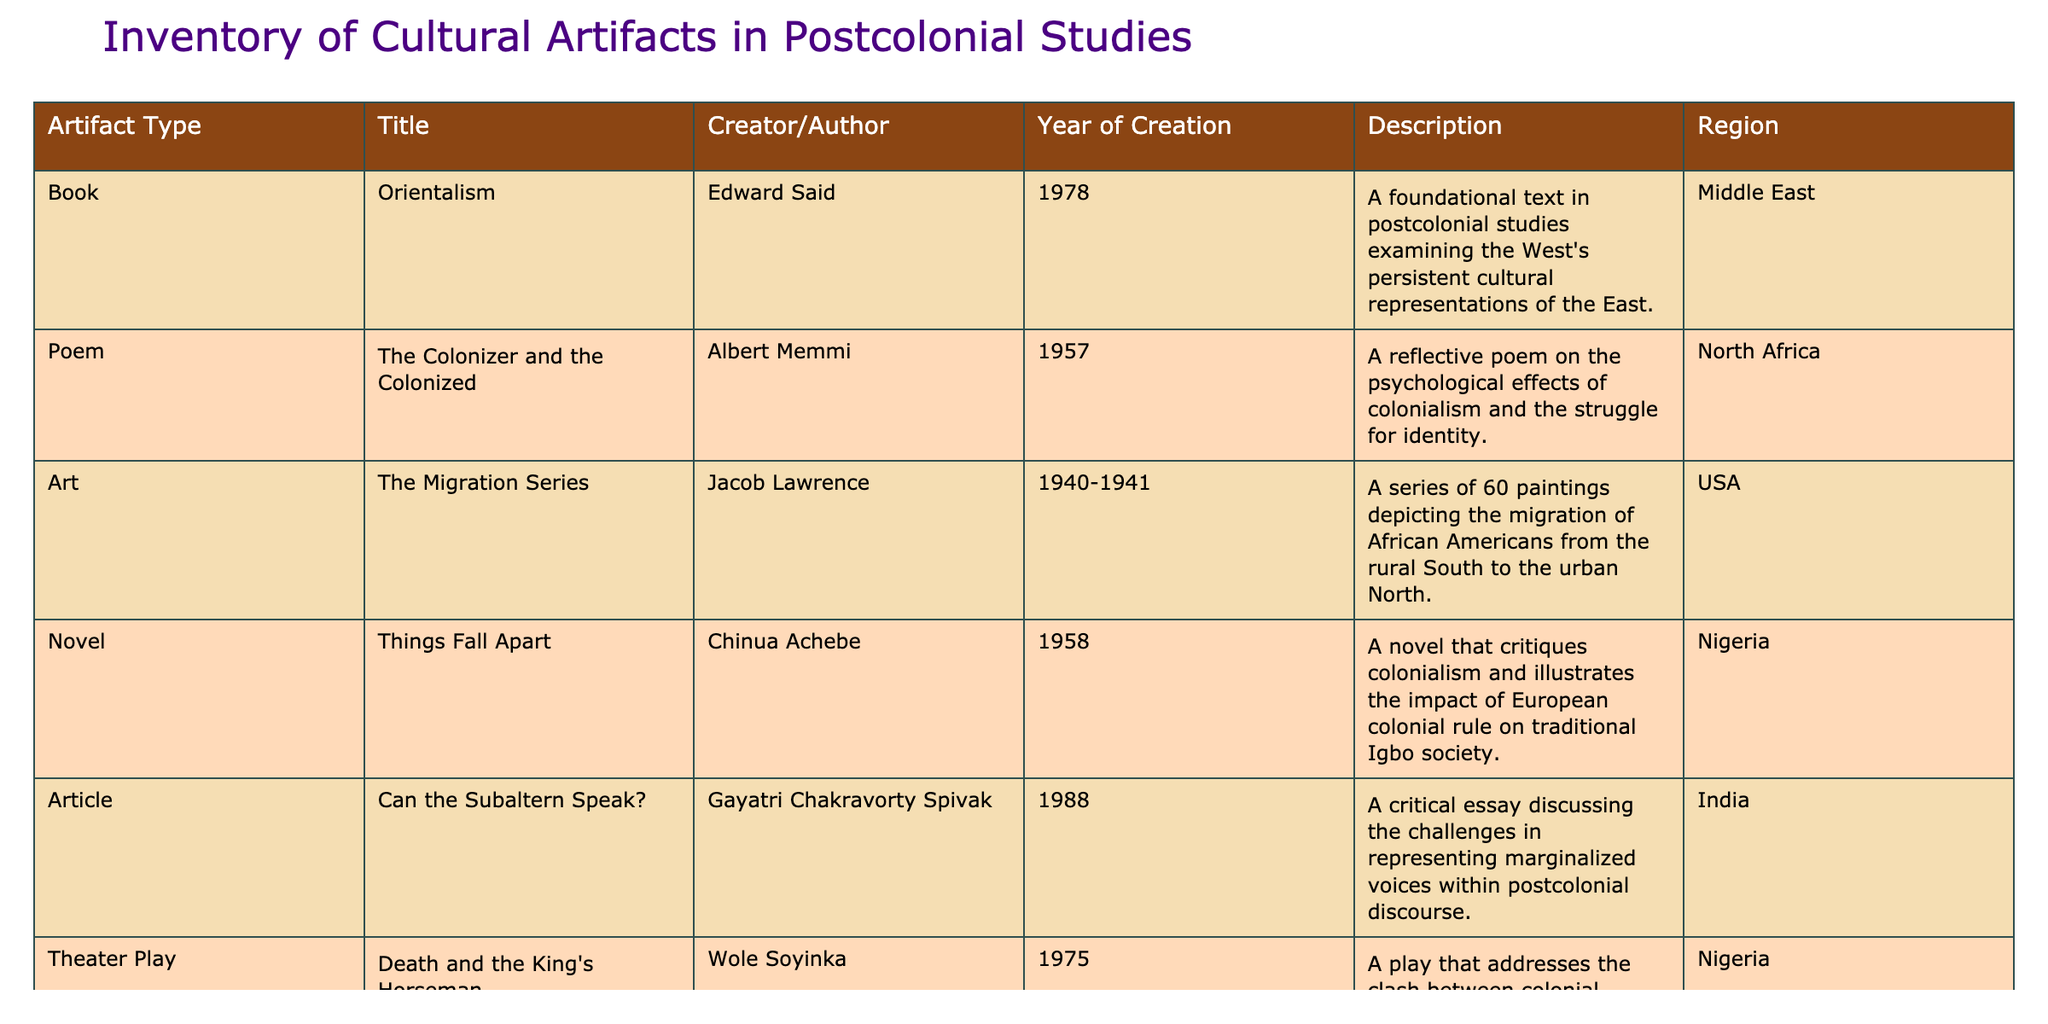What is the title of the book by Edward Said? The table lists Edward Said's work, which is classified as a book under "Title." The title mentioned alongside Edward Said is "Orientalism."
Answer: Orientalism How many artifacts listed were created by authors from Nigeria? The table shows two entries where the Region is Nigeria—"Things Fall Apart" by Chinua Achebe and "Death and the King's Horseman" by Wole Soyinka.
Answer: 2 Is "The Act of Killing" a novel? The table specifies that "The Act of Killing" is categorized as a documentary, not a novel; thus, the statement is false.
Answer: No What is the medium of "The Colonizer and the Colonized"? The table states that "The Colonizer and the Colonized" is classified as a poem. This is directly referenced in the Artifact Type column.
Answer: Poem Which artifact created in 1975 addresses colonial powers and indigenous practices? The table indicates that "Death and the King's Horseman," created in 1975, examines the interaction of colonial powers and local practices, fulfilling the criteria mentioned in the question.
Answer: Death and the King's Horseman What is the average year of creation for the artifacts listed in the table? The years of creation are: 1978, 1957, 1940, 1958, 1988, 1975, and 2012. Summing these gives 1978 + 1957 + 1940 + 1958 + 1988 + 1975 + 2012 = 13808. There are 7 artifacts, so the average year is 13808 / 7 = 1972.57, which rounds to 1973.
Answer: 1973 Which artifact is associated with the region "Middle East"? The table clearly shows that "Orientalism" by Edward Said is the only entry associated with the region "Middle East" in the table.
Answer: Orientalism Does any artifact in the table discuss the psychological effects of colonialism? The entry for "The Colonizer and the Colonized" by Albert Memmi explicitly notes it explores the psychological impacts of colonialism, confirming this statement as true.
Answer: Yes What is the latest year of creation for the artifacts listed? Reviewing the Years of Creation for the artifacts, "The Act of Killing" created in 2012 is the most recent.
Answer: 2012 